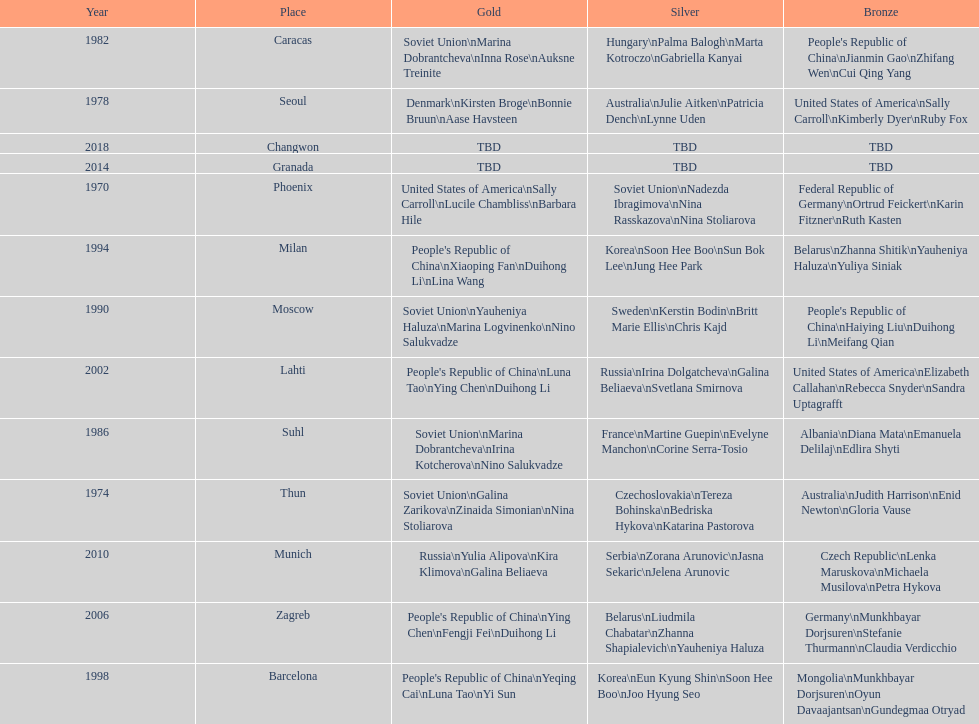How many times has germany won bronze? 2. 